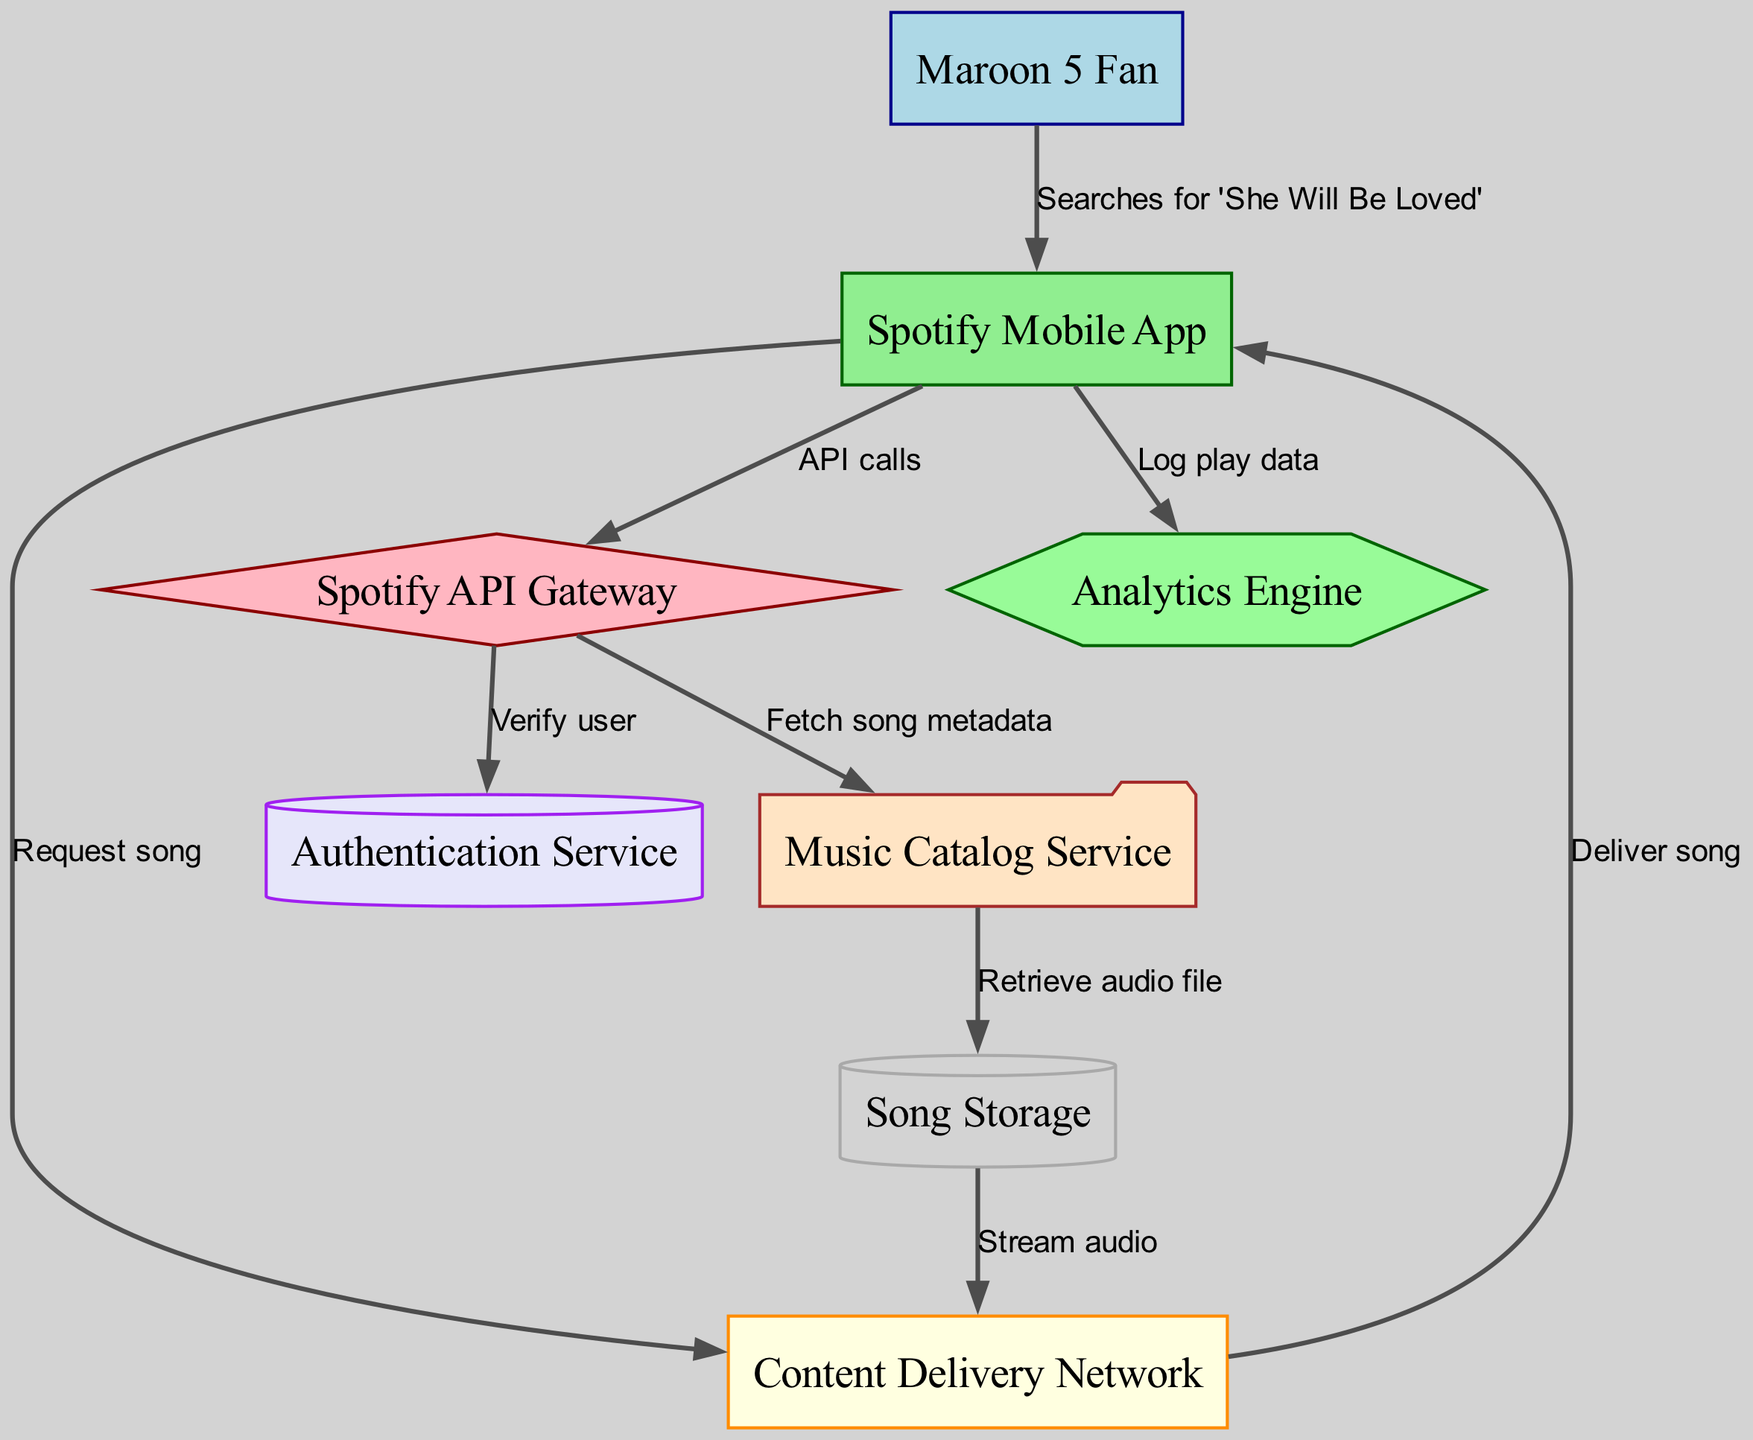What is the label of the node representing the user? The node representing the user is labeled "Maroon 5 Fan" according to the nodes defined in the data.
Answer: Maroon 5 Fan What does the node labeled "api" do? The node labeled "api" is defined as the "Spotify API Gateway" based on the provided nodes, which shows its function in the architecture.
Answer: Spotify API Gateway How many total nodes are present in the diagram? The diagram includes 8 nodes as listed in the data. Counting each individual node provides the total.
Answer: 8 What is the relationship between the "app" and the "cdn"? The relationship is described by the edge labeled "Request song," indicating that the app sends a request to the CDN for song delivery.
Answer: Request song Which service is responsible for verifying the user? The "Authentication Service" is responsible for user verification as indicated by the edge connected from the API to the Authentication Service.
Answer: Authentication Service What action does the "app" take to log play data? The "app" logs play data through an action labeled "Log play data" that connects it to the analytics engine in the diagram.
Answer: Log play data When a user searches for a song, which node do they interact with first? The user first interacts with the "Spotify Mobile App" when searching for a song, as shown by the edge leading from the user to the app.
Answer: Spotify Mobile App Which component retrieves the audio file for the song? The "Music Catalog Service" retrieves the audio file, as indicated by the flow from the catalog to the storage node.
Answer: Music Catalog Service How is the audio streamed to the app? The audio is streamed to the app through the "Content Delivery Network" after it is retrieved from storage, according to the flow diagram.
Answer: Content Delivery Network 